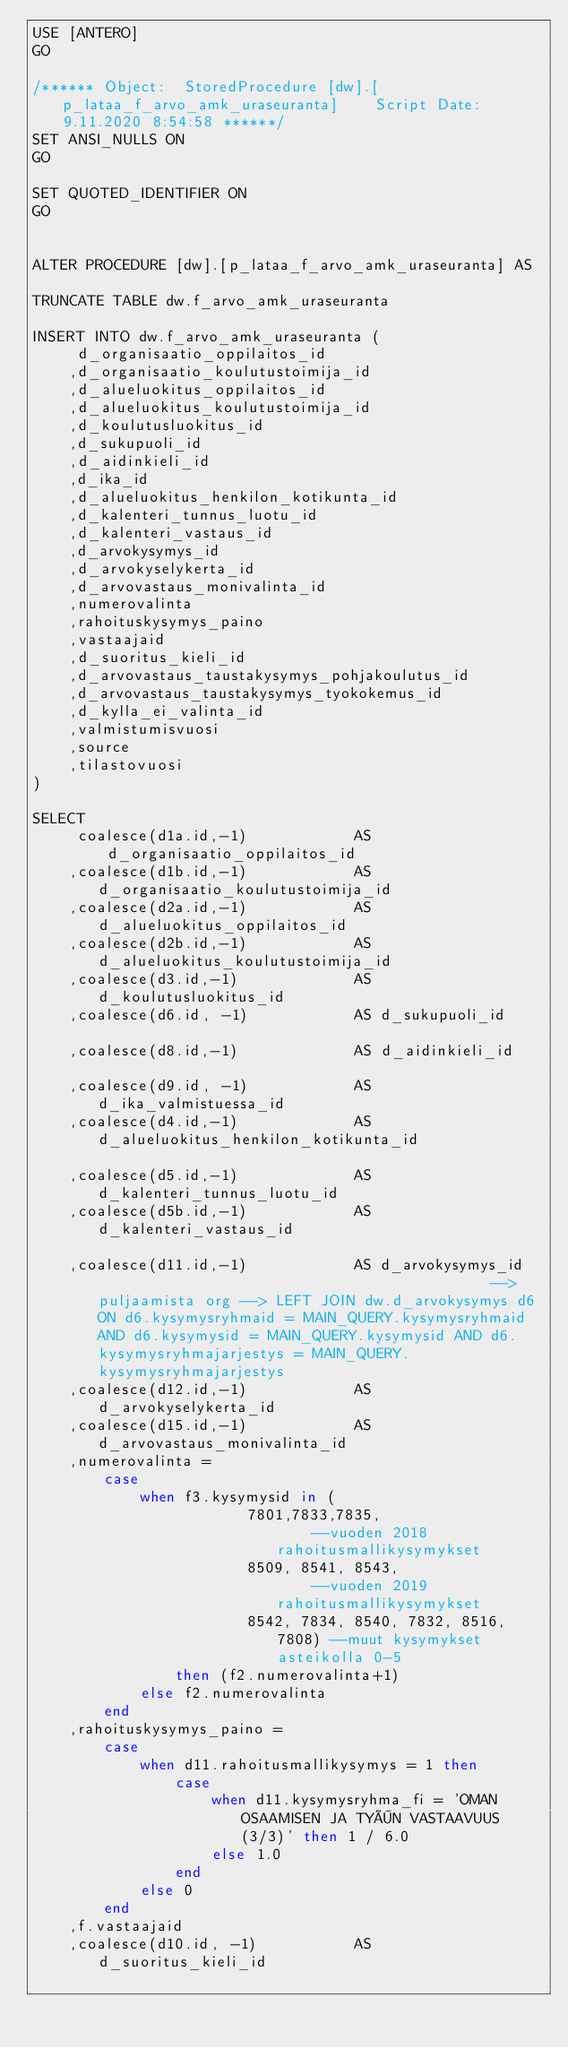<code> <loc_0><loc_0><loc_500><loc_500><_SQL_>USE [ANTERO]
GO

/****** Object:  StoredProcedure [dw].[p_lataa_f_arvo_amk_uraseuranta]    Script Date: 9.11.2020 8:54:58 ******/
SET ANSI_NULLS ON
GO

SET QUOTED_IDENTIFIER ON
GO


ALTER PROCEDURE [dw].[p_lataa_f_arvo_amk_uraseuranta] AS

TRUNCATE TABLE dw.f_arvo_amk_uraseuranta

INSERT INTO dw.f_arvo_amk_uraseuranta (
	 d_organisaatio_oppilaitos_id
	,d_organisaatio_koulutustoimija_id
	,d_alueluokitus_oppilaitos_id
	,d_alueluokitus_koulutustoimija_id
	,d_koulutusluokitus_id
	,d_sukupuoli_id 
	,d_aidinkieli_id 
	,d_ika_id
	,d_alueluokitus_henkilon_kotikunta_id
	,d_kalenteri_tunnus_luotu_id
	,d_kalenteri_vastaus_id
	,d_arvokysymys_id
	,d_arvokyselykerta_id
	,d_arvovastaus_monivalinta_id
	,numerovalinta
	,rahoituskysymys_paino
	,vastaajaid
	,d_suoritus_kieli_id
	,d_arvovastaus_taustakysymys_pohjakoulutus_id
	,d_arvovastaus_taustakysymys_tyokokemus_id
	,d_kylla_ei_valinta_id
	,valmistumisvuosi
	,source
	,tilastovuosi
)

SELECT 
     coalesce(d1a.id,-1)			AS d_organisaatio_oppilaitos_id
	,coalesce(d1b.id,-1)			AS d_organisaatio_koulutustoimija_id
	,coalesce(d2a.id,-1)			AS d_alueluokitus_oppilaitos_id
	,coalesce(d2b.id,-1)			AS d_alueluokitus_koulutustoimija_id
	,coalesce(d3.id,-1)				AS d_koulutusluokitus_id
	,coalesce(d6.id, -1)			AS d_sukupuoli_id						
	,coalesce(d8.id,-1)				AS d_aidinkieli_id							
	,coalesce(d9.id, -1) 			AS d_ika_valmistuessa_id					
	,coalesce(d4.id,-1)				AS d_alueluokitus_henkilon_kotikunta_id						
	,coalesce(d5.id,-1)				AS d_kalenteri_tunnus_luotu_id
	,coalesce(d5b.id,-1)			AS d_kalenteri_vastaus_id									
	,coalesce(d11.id,-1)			AS d_arvokysymys_id												--> puljaamista org --> LEFT JOIN dw.d_arvokysymys d6 ON d6.kysymysryhmaid = MAIN_QUERY.kysymysryhmaid AND d6.kysymysid = MAIN_QUERY.kysymysid AND d6.kysymysryhmajarjestys = MAIN_QUERY.kysymysryhmajarjestys
	,coalesce(d12.id,-1)			AS d_arvokyselykerta_id
	,coalesce(d15.id,-1)			AS d_arvovastaus_monivalinta_id			
	,numerovalinta = 
		case 
			when f3.kysymysid in (
						7801,7833,7835,						--vuoden 2018 rahoitusmallikysymykset
						8509, 8541, 8543,					--vuoden 2019 rahoitusmallikysymykset
						8542, 7834, 8540, 7832, 8516, 7808)	--muut kysymykset asteikolla 0-5
				then (f2.numerovalinta+1) 
			else f2.numerovalinta 
		end						
	,rahoituskysymys_paino = 
		case 
			when d11.rahoitusmallikysymys = 1 then
				case
					when d11.kysymysryhma_fi = 'OMAN OSAAMISEN JA TYÖN VASTAAVUUS (3/3)' then 1 / 6.0
					else 1.0
				end
			else 0
		end	
	,f.vastaajaid
	,coalesce(d10.id, -1)			AS d_suoritus_kieli_id												</code> 